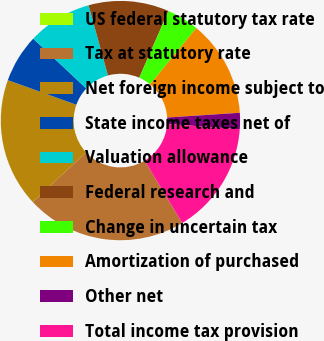Convert chart to OTSL. <chart><loc_0><loc_0><loc_500><loc_500><pie_chart><fcel>US federal statutory tax rate<fcel>Tax at statutory rate<fcel>Net foreign income subject to<fcel>State income taxes net of<fcel>Valuation allowance<fcel>Federal research and<fcel>Change in uncertain tax<fcel>Amortization of purchased<fcel>Other net<fcel>Total income tax provision<nl><fcel>0.0%<fcel>21.74%<fcel>17.39%<fcel>6.52%<fcel>8.7%<fcel>10.87%<fcel>4.35%<fcel>13.04%<fcel>2.18%<fcel>15.22%<nl></chart> 